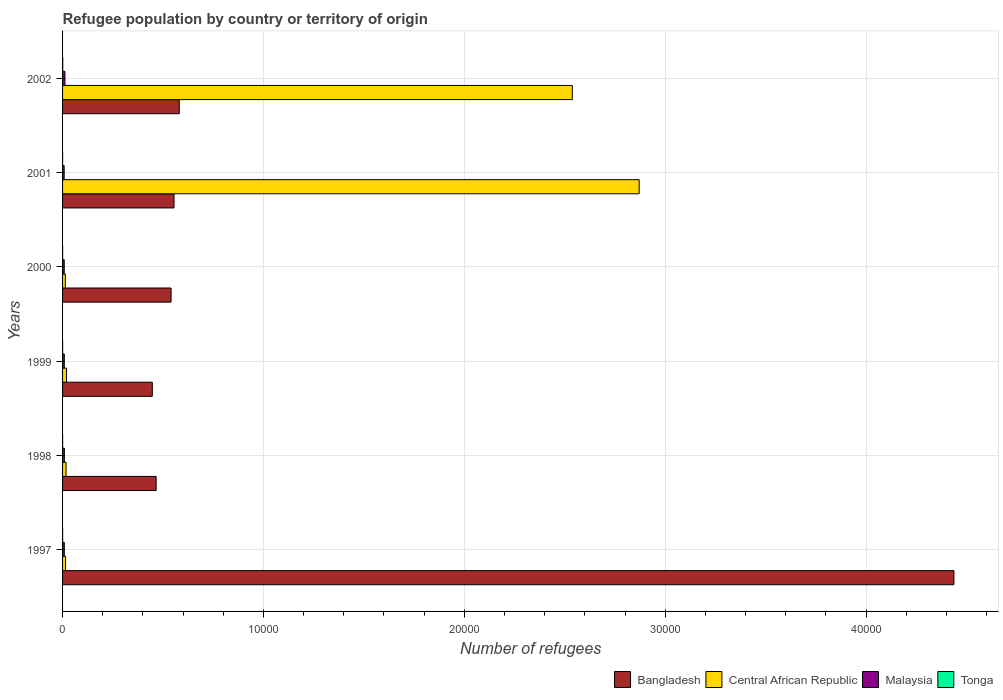How many different coloured bars are there?
Provide a succinct answer. 4. How many groups of bars are there?
Give a very brief answer. 6. Are the number of bars on each tick of the Y-axis equal?
Offer a very short reply. Yes. In how many cases, is the number of bars for a given year not equal to the number of legend labels?
Offer a terse response. 0. What is the number of refugees in Central African Republic in 2002?
Ensure brevity in your answer.  2.54e+04. Across all years, what is the maximum number of refugees in Malaysia?
Keep it short and to the point. 119. Across all years, what is the minimum number of refugees in Bangladesh?
Your answer should be compact. 4468. In which year was the number of refugees in Central African Republic maximum?
Your answer should be very brief. 2001. What is the total number of refugees in Malaysia in the graph?
Provide a succinct answer. 543. What is the difference between the number of refugees in Tonga in 1998 and the number of refugees in Malaysia in 2001?
Your response must be concise. -77. What is the average number of refugees in Bangladesh per year?
Ensure brevity in your answer.  1.17e+04. In the year 1999, what is the difference between the number of refugees in Tonga and number of refugees in Central African Republic?
Give a very brief answer. -194. What is the ratio of the number of refugees in Malaysia in 1997 to that in 1998?
Your answer should be very brief. 0.97. What is the difference between the highest and the lowest number of refugees in Tonga?
Your answer should be very brief. 7. In how many years, is the number of refugees in Central African Republic greater than the average number of refugees in Central African Republic taken over all years?
Give a very brief answer. 2. What does the 3rd bar from the top in 1998 represents?
Make the answer very short. Central African Republic. What does the 2nd bar from the bottom in 1998 represents?
Give a very brief answer. Central African Republic. Is it the case that in every year, the sum of the number of refugees in Central African Republic and number of refugees in Tonga is greater than the number of refugees in Bangladesh?
Keep it short and to the point. No. How many bars are there?
Provide a short and direct response. 24. Are all the bars in the graph horizontal?
Make the answer very short. Yes. What is the difference between two consecutive major ticks on the X-axis?
Your answer should be very brief. 10000. Are the values on the major ticks of X-axis written in scientific E-notation?
Provide a succinct answer. No. Does the graph contain any zero values?
Your answer should be compact. No. Does the graph contain grids?
Offer a very short reply. Yes. What is the title of the graph?
Keep it short and to the point. Refugee population by country or territory of origin. Does "Hong Kong" appear as one of the legend labels in the graph?
Offer a terse response. No. What is the label or title of the X-axis?
Provide a succinct answer. Number of refugees. What is the Number of refugees in Bangladesh in 1997?
Give a very brief answer. 4.44e+04. What is the Number of refugees of Central African Republic in 1997?
Your answer should be compact. 149. What is the Number of refugees in Malaysia in 1997?
Offer a terse response. 87. What is the Number of refugees in Tonga in 1997?
Give a very brief answer. 3. What is the Number of refugees of Bangladesh in 1998?
Ensure brevity in your answer.  4658. What is the Number of refugees in Central African Republic in 1998?
Offer a very short reply. 173. What is the Number of refugees of Malaysia in 1998?
Your response must be concise. 90. What is the Number of refugees of Bangladesh in 1999?
Ensure brevity in your answer.  4468. What is the Number of refugees in Central African Republic in 1999?
Ensure brevity in your answer.  196. What is the Number of refugees of Bangladesh in 2000?
Your answer should be compact. 5401. What is the Number of refugees of Central African Republic in 2000?
Provide a short and direct response. 139. What is the Number of refugees of Malaysia in 2000?
Offer a terse response. 82. What is the Number of refugees of Tonga in 2000?
Offer a terse response. 3. What is the Number of refugees in Bangladesh in 2001?
Give a very brief answer. 5548. What is the Number of refugees of Central African Republic in 2001?
Your response must be concise. 2.87e+04. What is the Number of refugees in Malaysia in 2001?
Ensure brevity in your answer.  79. What is the Number of refugees of Tonga in 2001?
Provide a succinct answer. 1. What is the Number of refugees of Bangladesh in 2002?
Make the answer very short. 5808. What is the Number of refugees of Central African Republic in 2002?
Offer a terse response. 2.54e+04. What is the Number of refugees in Malaysia in 2002?
Your answer should be compact. 119. What is the Number of refugees of Tonga in 2002?
Keep it short and to the point. 8. Across all years, what is the maximum Number of refugees of Bangladesh?
Your response must be concise. 4.44e+04. Across all years, what is the maximum Number of refugees in Central African Republic?
Provide a succinct answer. 2.87e+04. Across all years, what is the maximum Number of refugees in Malaysia?
Offer a terse response. 119. Across all years, what is the minimum Number of refugees of Bangladesh?
Give a very brief answer. 4468. Across all years, what is the minimum Number of refugees in Central African Republic?
Offer a very short reply. 139. Across all years, what is the minimum Number of refugees in Malaysia?
Provide a succinct answer. 79. What is the total Number of refugees in Bangladesh in the graph?
Give a very brief answer. 7.03e+04. What is the total Number of refugees of Central African Republic in the graph?
Your answer should be very brief. 5.47e+04. What is the total Number of refugees of Malaysia in the graph?
Give a very brief answer. 543. What is the difference between the Number of refugees in Bangladesh in 1997 and that in 1998?
Provide a succinct answer. 3.97e+04. What is the difference between the Number of refugees in Tonga in 1997 and that in 1998?
Offer a very short reply. 1. What is the difference between the Number of refugees in Bangladesh in 1997 and that in 1999?
Provide a short and direct response. 3.99e+04. What is the difference between the Number of refugees of Central African Republic in 1997 and that in 1999?
Give a very brief answer. -47. What is the difference between the Number of refugees of Malaysia in 1997 and that in 1999?
Provide a succinct answer. 1. What is the difference between the Number of refugees in Bangladesh in 1997 and that in 2000?
Your response must be concise. 3.90e+04. What is the difference between the Number of refugees of Malaysia in 1997 and that in 2000?
Give a very brief answer. 5. What is the difference between the Number of refugees in Bangladesh in 1997 and that in 2001?
Offer a very short reply. 3.88e+04. What is the difference between the Number of refugees of Central African Republic in 1997 and that in 2001?
Give a very brief answer. -2.86e+04. What is the difference between the Number of refugees in Malaysia in 1997 and that in 2001?
Offer a very short reply. 8. What is the difference between the Number of refugees in Bangladesh in 1997 and that in 2002?
Provide a succinct answer. 3.86e+04. What is the difference between the Number of refugees in Central African Republic in 1997 and that in 2002?
Give a very brief answer. -2.52e+04. What is the difference between the Number of refugees of Malaysia in 1997 and that in 2002?
Keep it short and to the point. -32. What is the difference between the Number of refugees of Bangladesh in 1998 and that in 1999?
Your answer should be compact. 190. What is the difference between the Number of refugees in Tonga in 1998 and that in 1999?
Provide a succinct answer. 0. What is the difference between the Number of refugees of Bangladesh in 1998 and that in 2000?
Offer a terse response. -743. What is the difference between the Number of refugees of Central African Republic in 1998 and that in 2000?
Keep it short and to the point. 34. What is the difference between the Number of refugees in Malaysia in 1998 and that in 2000?
Keep it short and to the point. 8. What is the difference between the Number of refugees in Tonga in 1998 and that in 2000?
Your response must be concise. -1. What is the difference between the Number of refugees of Bangladesh in 1998 and that in 2001?
Give a very brief answer. -890. What is the difference between the Number of refugees of Central African Republic in 1998 and that in 2001?
Offer a terse response. -2.85e+04. What is the difference between the Number of refugees of Malaysia in 1998 and that in 2001?
Provide a succinct answer. 11. What is the difference between the Number of refugees in Tonga in 1998 and that in 2001?
Make the answer very short. 1. What is the difference between the Number of refugees of Bangladesh in 1998 and that in 2002?
Your answer should be compact. -1150. What is the difference between the Number of refugees of Central African Republic in 1998 and that in 2002?
Ensure brevity in your answer.  -2.52e+04. What is the difference between the Number of refugees in Tonga in 1998 and that in 2002?
Offer a terse response. -6. What is the difference between the Number of refugees in Bangladesh in 1999 and that in 2000?
Offer a terse response. -933. What is the difference between the Number of refugees in Central African Republic in 1999 and that in 2000?
Give a very brief answer. 57. What is the difference between the Number of refugees in Tonga in 1999 and that in 2000?
Keep it short and to the point. -1. What is the difference between the Number of refugees of Bangladesh in 1999 and that in 2001?
Ensure brevity in your answer.  -1080. What is the difference between the Number of refugees in Central African Republic in 1999 and that in 2001?
Provide a succinct answer. -2.85e+04. What is the difference between the Number of refugees of Malaysia in 1999 and that in 2001?
Give a very brief answer. 7. What is the difference between the Number of refugees of Bangladesh in 1999 and that in 2002?
Provide a succinct answer. -1340. What is the difference between the Number of refugees in Central African Republic in 1999 and that in 2002?
Offer a terse response. -2.52e+04. What is the difference between the Number of refugees of Malaysia in 1999 and that in 2002?
Make the answer very short. -33. What is the difference between the Number of refugees in Tonga in 1999 and that in 2002?
Ensure brevity in your answer.  -6. What is the difference between the Number of refugees of Bangladesh in 2000 and that in 2001?
Provide a short and direct response. -147. What is the difference between the Number of refugees in Central African Republic in 2000 and that in 2001?
Offer a very short reply. -2.86e+04. What is the difference between the Number of refugees of Malaysia in 2000 and that in 2001?
Give a very brief answer. 3. What is the difference between the Number of refugees in Bangladesh in 2000 and that in 2002?
Your answer should be very brief. -407. What is the difference between the Number of refugees in Central African Republic in 2000 and that in 2002?
Your answer should be very brief. -2.52e+04. What is the difference between the Number of refugees in Malaysia in 2000 and that in 2002?
Ensure brevity in your answer.  -37. What is the difference between the Number of refugees of Tonga in 2000 and that in 2002?
Your answer should be very brief. -5. What is the difference between the Number of refugees in Bangladesh in 2001 and that in 2002?
Your answer should be very brief. -260. What is the difference between the Number of refugees in Central African Republic in 2001 and that in 2002?
Offer a very short reply. 3328. What is the difference between the Number of refugees of Bangladesh in 1997 and the Number of refugees of Central African Republic in 1998?
Your answer should be compact. 4.42e+04. What is the difference between the Number of refugees of Bangladesh in 1997 and the Number of refugees of Malaysia in 1998?
Ensure brevity in your answer.  4.43e+04. What is the difference between the Number of refugees in Bangladesh in 1997 and the Number of refugees in Tonga in 1998?
Give a very brief answer. 4.44e+04. What is the difference between the Number of refugees in Central African Republic in 1997 and the Number of refugees in Tonga in 1998?
Make the answer very short. 147. What is the difference between the Number of refugees in Bangladesh in 1997 and the Number of refugees in Central African Republic in 1999?
Provide a succinct answer. 4.42e+04. What is the difference between the Number of refugees of Bangladesh in 1997 and the Number of refugees of Malaysia in 1999?
Your response must be concise. 4.43e+04. What is the difference between the Number of refugees of Bangladesh in 1997 and the Number of refugees of Tonga in 1999?
Give a very brief answer. 4.44e+04. What is the difference between the Number of refugees in Central African Republic in 1997 and the Number of refugees in Tonga in 1999?
Offer a terse response. 147. What is the difference between the Number of refugees of Malaysia in 1997 and the Number of refugees of Tonga in 1999?
Your answer should be compact. 85. What is the difference between the Number of refugees of Bangladesh in 1997 and the Number of refugees of Central African Republic in 2000?
Keep it short and to the point. 4.42e+04. What is the difference between the Number of refugees in Bangladesh in 1997 and the Number of refugees in Malaysia in 2000?
Make the answer very short. 4.43e+04. What is the difference between the Number of refugees of Bangladesh in 1997 and the Number of refugees of Tonga in 2000?
Your response must be concise. 4.44e+04. What is the difference between the Number of refugees of Central African Republic in 1997 and the Number of refugees of Malaysia in 2000?
Your answer should be very brief. 67. What is the difference between the Number of refugees in Central African Republic in 1997 and the Number of refugees in Tonga in 2000?
Your answer should be compact. 146. What is the difference between the Number of refugees of Bangladesh in 1997 and the Number of refugees of Central African Republic in 2001?
Your response must be concise. 1.57e+04. What is the difference between the Number of refugees of Bangladesh in 1997 and the Number of refugees of Malaysia in 2001?
Your answer should be very brief. 4.43e+04. What is the difference between the Number of refugees in Bangladesh in 1997 and the Number of refugees in Tonga in 2001?
Offer a very short reply. 4.44e+04. What is the difference between the Number of refugees in Central African Republic in 1997 and the Number of refugees in Tonga in 2001?
Your answer should be very brief. 148. What is the difference between the Number of refugees of Bangladesh in 1997 and the Number of refugees of Central African Republic in 2002?
Your answer should be very brief. 1.90e+04. What is the difference between the Number of refugees in Bangladesh in 1997 and the Number of refugees in Malaysia in 2002?
Your answer should be very brief. 4.43e+04. What is the difference between the Number of refugees in Bangladesh in 1997 and the Number of refugees in Tonga in 2002?
Keep it short and to the point. 4.44e+04. What is the difference between the Number of refugees in Central African Republic in 1997 and the Number of refugees in Malaysia in 2002?
Provide a short and direct response. 30. What is the difference between the Number of refugees of Central African Republic in 1997 and the Number of refugees of Tonga in 2002?
Give a very brief answer. 141. What is the difference between the Number of refugees of Malaysia in 1997 and the Number of refugees of Tonga in 2002?
Offer a terse response. 79. What is the difference between the Number of refugees in Bangladesh in 1998 and the Number of refugees in Central African Republic in 1999?
Offer a very short reply. 4462. What is the difference between the Number of refugees in Bangladesh in 1998 and the Number of refugees in Malaysia in 1999?
Ensure brevity in your answer.  4572. What is the difference between the Number of refugees of Bangladesh in 1998 and the Number of refugees of Tonga in 1999?
Give a very brief answer. 4656. What is the difference between the Number of refugees of Central African Republic in 1998 and the Number of refugees of Tonga in 1999?
Your answer should be compact. 171. What is the difference between the Number of refugees in Bangladesh in 1998 and the Number of refugees in Central African Republic in 2000?
Your answer should be compact. 4519. What is the difference between the Number of refugees of Bangladesh in 1998 and the Number of refugees of Malaysia in 2000?
Give a very brief answer. 4576. What is the difference between the Number of refugees in Bangladesh in 1998 and the Number of refugees in Tonga in 2000?
Your answer should be compact. 4655. What is the difference between the Number of refugees in Central African Republic in 1998 and the Number of refugees in Malaysia in 2000?
Provide a short and direct response. 91. What is the difference between the Number of refugees in Central African Republic in 1998 and the Number of refugees in Tonga in 2000?
Your answer should be very brief. 170. What is the difference between the Number of refugees of Malaysia in 1998 and the Number of refugees of Tonga in 2000?
Your answer should be very brief. 87. What is the difference between the Number of refugees in Bangladesh in 1998 and the Number of refugees in Central African Republic in 2001?
Offer a very short reply. -2.40e+04. What is the difference between the Number of refugees in Bangladesh in 1998 and the Number of refugees in Malaysia in 2001?
Give a very brief answer. 4579. What is the difference between the Number of refugees in Bangladesh in 1998 and the Number of refugees in Tonga in 2001?
Keep it short and to the point. 4657. What is the difference between the Number of refugees of Central African Republic in 1998 and the Number of refugees of Malaysia in 2001?
Provide a short and direct response. 94. What is the difference between the Number of refugees in Central African Republic in 1998 and the Number of refugees in Tonga in 2001?
Keep it short and to the point. 172. What is the difference between the Number of refugees of Malaysia in 1998 and the Number of refugees of Tonga in 2001?
Your answer should be compact. 89. What is the difference between the Number of refugees in Bangladesh in 1998 and the Number of refugees in Central African Republic in 2002?
Offer a terse response. -2.07e+04. What is the difference between the Number of refugees of Bangladesh in 1998 and the Number of refugees of Malaysia in 2002?
Provide a short and direct response. 4539. What is the difference between the Number of refugees in Bangladesh in 1998 and the Number of refugees in Tonga in 2002?
Your answer should be very brief. 4650. What is the difference between the Number of refugees of Central African Republic in 1998 and the Number of refugees of Malaysia in 2002?
Make the answer very short. 54. What is the difference between the Number of refugees of Central African Republic in 1998 and the Number of refugees of Tonga in 2002?
Provide a short and direct response. 165. What is the difference between the Number of refugees in Malaysia in 1998 and the Number of refugees in Tonga in 2002?
Your response must be concise. 82. What is the difference between the Number of refugees of Bangladesh in 1999 and the Number of refugees of Central African Republic in 2000?
Provide a succinct answer. 4329. What is the difference between the Number of refugees in Bangladesh in 1999 and the Number of refugees in Malaysia in 2000?
Your answer should be compact. 4386. What is the difference between the Number of refugees of Bangladesh in 1999 and the Number of refugees of Tonga in 2000?
Give a very brief answer. 4465. What is the difference between the Number of refugees in Central African Republic in 1999 and the Number of refugees in Malaysia in 2000?
Give a very brief answer. 114. What is the difference between the Number of refugees in Central African Republic in 1999 and the Number of refugees in Tonga in 2000?
Provide a succinct answer. 193. What is the difference between the Number of refugees in Malaysia in 1999 and the Number of refugees in Tonga in 2000?
Offer a very short reply. 83. What is the difference between the Number of refugees of Bangladesh in 1999 and the Number of refugees of Central African Republic in 2001?
Ensure brevity in your answer.  -2.42e+04. What is the difference between the Number of refugees in Bangladesh in 1999 and the Number of refugees in Malaysia in 2001?
Make the answer very short. 4389. What is the difference between the Number of refugees of Bangladesh in 1999 and the Number of refugees of Tonga in 2001?
Offer a terse response. 4467. What is the difference between the Number of refugees of Central African Republic in 1999 and the Number of refugees of Malaysia in 2001?
Give a very brief answer. 117. What is the difference between the Number of refugees in Central African Republic in 1999 and the Number of refugees in Tonga in 2001?
Give a very brief answer. 195. What is the difference between the Number of refugees in Bangladesh in 1999 and the Number of refugees in Central African Republic in 2002?
Your answer should be very brief. -2.09e+04. What is the difference between the Number of refugees of Bangladesh in 1999 and the Number of refugees of Malaysia in 2002?
Ensure brevity in your answer.  4349. What is the difference between the Number of refugees in Bangladesh in 1999 and the Number of refugees in Tonga in 2002?
Your response must be concise. 4460. What is the difference between the Number of refugees of Central African Republic in 1999 and the Number of refugees of Tonga in 2002?
Keep it short and to the point. 188. What is the difference between the Number of refugees in Malaysia in 1999 and the Number of refugees in Tonga in 2002?
Offer a terse response. 78. What is the difference between the Number of refugees in Bangladesh in 2000 and the Number of refugees in Central African Republic in 2001?
Provide a short and direct response. -2.33e+04. What is the difference between the Number of refugees in Bangladesh in 2000 and the Number of refugees in Malaysia in 2001?
Provide a succinct answer. 5322. What is the difference between the Number of refugees in Bangladesh in 2000 and the Number of refugees in Tonga in 2001?
Ensure brevity in your answer.  5400. What is the difference between the Number of refugees of Central African Republic in 2000 and the Number of refugees of Tonga in 2001?
Give a very brief answer. 138. What is the difference between the Number of refugees of Malaysia in 2000 and the Number of refugees of Tonga in 2001?
Offer a very short reply. 81. What is the difference between the Number of refugees of Bangladesh in 2000 and the Number of refugees of Central African Republic in 2002?
Keep it short and to the point. -2.00e+04. What is the difference between the Number of refugees of Bangladesh in 2000 and the Number of refugees of Malaysia in 2002?
Offer a very short reply. 5282. What is the difference between the Number of refugees in Bangladesh in 2000 and the Number of refugees in Tonga in 2002?
Your answer should be compact. 5393. What is the difference between the Number of refugees in Central African Republic in 2000 and the Number of refugees in Malaysia in 2002?
Offer a terse response. 20. What is the difference between the Number of refugees in Central African Republic in 2000 and the Number of refugees in Tonga in 2002?
Offer a very short reply. 131. What is the difference between the Number of refugees in Malaysia in 2000 and the Number of refugees in Tonga in 2002?
Your answer should be compact. 74. What is the difference between the Number of refugees in Bangladesh in 2001 and the Number of refugees in Central African Republic in 2002?
Provide a succinct answer. -1.98e+04. What is the difference between the Number of refugees in Bangladesh in 2001 and the Number of refugees in Malaysia in 2002?
Your response must be concise. 5429. What is the difference between the Number of refugees in Bangladesh in 2001 and the Number of refugees in Tonga in 2002?
Your answer should be very brief. 5540. What is the difference between the Number of refugees of Central African Republic in 2001 and the Number of refugees of Malaysia in 2002?
Provide a short and direct response. 2.86e+04. What is the difference between the Number of refugees in Central African Republic in 2001 and the Number of refugees in Tonga in 2002?
Offer a terse response. 2.87e+04. What is the average Number of refugees in Bangladesh per year?
Provide a succinct answer. 1.17e+04. What is the average Number of refugees in Central African Republic per year?
Offer a terse response. 9122.83. What is the average Number of refugees in Malaysia per year?
Your answer should be very brief. 90.5. What is the average Number of refugees in Tonga per year?
Make the answer very short. 3.17. In the year 1997, what is the difference between the Number of refugees of Bangladesh and Number of refugees of Central African Republic?
Offer a terse response. 4.42e+04. In the year 1997, what is the difference between the Number of refugees in Bangladesh and Number of refugees in Malaysia?
Offer a very short reply. 4.43e+04. In the year 1997, what is the difference between the Number of refugees in Bangladesh and Number of refugees in Tonga?
Your answer should be compact. 4.44e+04. In the year 1997, what is the difference between the Number of refugees in Central African Republic and Number of refugees in Malaysia?
Your response must be concise. 62. In the year 1997, what is the difference between the Number of refugees of Central African Republic and Number of refugees of Tonga?
Your response must be concise. 146. In the year 1998, what is the difference between the Number of refugees in Bangladesh and Number of refugees in Central African Republic?
Your answer should be very brief. 4485. In the year 1998, what is the difference between the Number of refugees in Bangladesh and Number of refugees in Malaysia?
Offer a very short reply. 4568. In the year 1998, what is the difference between the Number of refugees in Bangladesh and Number of refugees in Tonga?
Give a very brief answer. 4656. In the year 1998, what is the difference between the Number of refugees of Central African Republic and Number of refugees of Malaysia?
Offer a very short reply. 83. In the year 1998, what is the difference between the Number of refugees in Central African Republic and Number of refugees in Tonga?
Give a very brief answer. 171. In the year 1998, what is the difference between the Number of refugees in Malaysia and Number of refugees in Tonga?
Offer a very short reply. 88. In the year 1999, what is the difference between the Number of refugees of Bangladesh and Number of refugees of Central African Republic?
Offer a very short reply. 4272. In the year 1999, what is the difference between the Number of refugees in Bangladesh and Number of refugees in Malaysia?
Your answer should be very brief. 4382. In the year 1999, what is the difference between the Number of refugees in Bangladesh and Number of refugees in Tonga?
Offer a terse response. 4466. In the year 1999, what is the difference between the Number of refugees in Central African Republic and Number of refugees in Malaysia?
Your answer should be compact. 110. In the year 1999, what is the difference between the Number of refugees in Central African Republic and Number of refugees in Tonga?
Keep it short and to the point. 194. In the year 2000, what is the difference between the Number of refugees in Bangladesh and Number of refugees in Central African Republic?
Make the answer very short. 5262. In the year 2000, what is the difference between the Number of refugees of Bangladesh and Number of refugees of Malaysia?
Make the answer very short. 5319. In the year 2000, what is the difference between the Number of refugees in Bangladesh and Number of refugees in Tonga?
Your answer should be very brief. 5398. In the year 2000, what is the difference between the Number of refugees in Central African Republic and Number of refugees in Tonga?
Your answer should be very brief. 136. In the year 2000, what is the difference between the Number of refugees of Malaysia and Number of refugees of Tonga?
Your response must be concise. 79. In the year 2001, what is the difference between the Number of refugees of Bangladesh and Number of refugees of Central African Republic?
Offer a terse response. -2.32e+04. In the year 2001, what is the difference between the Number of refugees in Bangladesh and Number of refugees in Malaysia?
Your response must be concise. 5469. In the year 2001, what is the difference between the Number of refugees in Bangladesh and Number of refugees in Tonga?
Your answer should be very brief. 5547. In the year 2001, what is the difference between the Number of refugees of Central African Republic and Number of refugees of Malaysia?
Your response must be concise. 2.86e+04. In the year 2001, what is the difference between the Number of refugees in Central African Republic and Number of refugees in Tonga?
Ensure brevity in your answer.  2.87e+04. In the year 2001, what is the difference between the Number of refugees in Malaysia and Number of refugees in Tonga?
Offer a very short reply. 78. In the year 2002, what is the difference between the Number of refugees in Bangladesh and Number of refugees in Central African Republic?
Offer a very short reply. -1.96e+04. In the year 2002, what is the difference between the Number of refugees of Bangladesh and Number of refugees of Malaysia?
Make the answer very short. 5689. In the year 2002, what is the difference between the Number of refugees of Bangladesh and Number of refugees of Tonga?
Give a very brief answer. 5800. In the year 2002, what is the difference between the Number of refugees in Central African Republic and Number of refugees in Malaysia?
Ensure brevity in your answer.  2.53e+04. In the year 2002, what is the difference between the Number of refugees of Central African Republic and Number of refugees of Tonga?
Offer a terse response. 2.54e+04. In the year 2002, what is the difference between the Number of refugees of Malaysia and Number of refugees of Tonga?
Your answer should be compact. 111. What is the ratio of the Number of refugees of Bangladesh in 1997 to that in 1998?
Your answer should be very brief. 9.53. What is the ratio of the Number of refugees in Central African Republic in 1997 to that in 1998?
Make the answer very short. 0.86. What is the ratio of the Number of refugees in Malaysia in 1997 to that in 1998?
Ensure brevity in your answer.  0.97. What is the ratio of the Number of refugees of Tonga in 1997 to that in 1998?
Offer a very short reply. 1.5. What is the ratio of the Number of refugees of Bangladesh in 1997 to that in 1999?
Provide a succinct answer. 9.93. What is the ratio of the Number of refugees of Central African Republic in 1997 to that in 1999?
Your response must be concise. 0.76. What is the ratio of the Number of refugees of Malaysia in 1997 to that in 1999?
Your answer should be very brief. 1.01. What is the ratio of the Number of refugees in Bangladesh in 1997 to that in 2000?
Offer a terse response. 8.22. What is the ratio of the Number of refugees in Central African Republic in 1997 to that in 2000?
Make the answer very short. 1.07. What is the ratio of the Number of refugees in Malaysia in 1997 to that in 2000?
Your answer should be very brief. 1.06. What is the ratio of the Number of refugees of Tonga in 1997 to that in 2000?
Offer a terse response. 1. What is the ratio of the Number of refugees in Bangladesh in 1997 to that in 2001?
Your answer should be very brief. 8. What is the ratio of the Number of refugees in Central African Republic in 1997 to that in 2001?
Your response must be concise. 0.01. What is the ratio of the Number of refugees of Malaysia in 1997 to that in 2001?
Your response must be concise. 1.1. What is the ratio of the Number of refugees in Bangladesh in 1997 to that in 2002?
Your response must be concise. 7.64. What is the ratio of the Number of refugees of Central African Republic in 1997 to that in 2002?
Keep it short and to the point. 0.01. What is the ratio of the Number of refugees of Malaysia in 1997 to that in 2002?
Provide a succinct answer. 0.73. What is the ratio of the Number of refugees of Bangladesh in 1998 to that in 1999?
Your answer should be compact. 1.04. What is the ratio of the Number of refugees of Central African Republic in 1998 to that in 1999?
Offer a terse response. 0.88. What is the ratio of the Number of refugees in Malaysia in 1998 to that in 1999?
Keep it short and to the point. 1.05. What is the ratio of the Number of refugees in Bangladesh in 1998 to that in 2000?
Your answer should be very brief. 0.86. What is the ratio of the Number of refugees in Central African Republic in 1998 to that in 2000?
Your answer should be very brief. 1.24. What is the ratio of the Number of refugees of Malaysia in 1998 to that in 2000?
Give a very brief answer. 1.1. What is the ratio of the Number of refugees of Bangladesh in 1998 to that in 2001?
Keep it short and to the point. 0.84. What is the ratio of the Number of refugees in Central African Republic in 1998 to that in 2001?
Your response must be concise. 0.01. What is the ratio of the Number of refugees of Malaysia in 1998 to that in 2001?
Your answer should be very brief. 1.14. What is the ratio of the Number of refugees of Bangladesh in 1998 to that in 2002?
Give a very brief answer. 0.8. What is the ratio of the Number of refugees in Central African Republic in 1998 to that in 2002?
Provide a succinct answer. 0.01. What is the ratio of the Number of refugees in Malaysia in 1998 to that in 2002?
Keep it short and to the point. 0.76. What is the ratio of the Number of refugees of Bangladesh in 1999 to that in 2000?
Your answer should be compact. 0.83. What is the ratio of the Number of refugees in Central African Republic in 1999 to that in 2000?
Keep it short and to the point. 1.41. What is the ratio of the Number of refugees of Malaysia in 1999 to that in 2000?
Make the answer very short. 1.05. What is the ratio of the Number of refugees in Tonga in 1999 to that in 2000?
Provide a succinct answer. 0.67. What is the ratio of the Number of refugees in Bangladesh in 1999 to that in 2001?
Offer a terse response. 0.81. What is the ratio of the Number of refugees in Central African Republic in 1999 to that in 2001?
Provide a succinct answer. 0.01. What is the ratio of the Number of refugees of Malaysia in 1999 to that in 2001?
Your response must be concise. 1.09. What is the ratio of the Number of refugees of Tonga in 1999 to that in 2001?
Offer a very short reply. 2. What is the ratio of the Number of refugees in Bangladesh in 1999 to that in 2002?
Ensure brevity in your answer.  0.77. What is the ratio of the Number of refugees of Central African Republic in 1999 to that in 2002?
Your answer should be very brief. 0.01. What is the ratio of the Number of refugees in Malaysia in 1999 to that in 2002?
Your answer should be very brief. 0.72. What is the ratio of the Number of refugees of Tonga in 1999 to that in 2002?
Give a very brief answer. 0.25. What is the ratio of the Number of refugees of Bangladesh in 2000 to that in 2001?
Your answer should be very brief. 0.97. What is the ratio of the Number of refugees in Central African Republic in 2000 to that in 2001?
Provide a short and direct response. 0. What is the ratio of the Number of refugees in Malaysia in 2000 to that in 2001?
Offer a terse response. 1.04. What is the ratio of the Number of refugees in Bangladesh in 2000 to that in 2002?
Offer a terse response. 0.93. What is the ratio of the Number of refugees in Central African Republic in 2000 to that in 2002?
Provide a succinct answer. 0.01. What is the ratio of the Number of refugees in Malaysia in 2000 to that in 2002?
Make the answer very short. 0.69. What is the ratio of the Number of refugees of Tonga in 2000 to that in 2002?
Provide a succinct answer. 0.38. What is the ratio of the Number of refugees in Bangladesh in 2001 to that in 2002?
Offer a terse response. 0.96. What is the ratio of the Number of refugees of Central African Republic in 2001 to that in 2002?
Ensure brevity in your answer.  1.13. What is the ratio of the Number of refugees in Malaysia in 2001 to that in 2002?
Provide a succinct answer. 0.66. What is the difference between the highest and the second highest Number of refugees of Bangladesh?
Your response must be concise. 3.86e+04. What is the difference between the highest and the second highest Number of refugees of Central African Republic?
Offer a very short reply. 3328. What is the difference between the highest and the second highest Number of refugees of Malaysia?
Keep it short and to the point. 29. What is the difference between the highest and the second highest Number of refugees of Tonga?
Your answer should be compact. 5. What is the difference between the highest and the lowest Number of refugees of Bangladesh?
Offer a very short reply. 3.99e+04. What is the difference between the highest and the lowest Number of refugees in Central African Republic?
Your answer should be very brief. 2.86e+04. What is the difference between the highest and the lowest Number of refugees of Malaysia?
Offer a terse response. 40. What is the difference between the highest and the lowest Number of refugees of Tonga?
Provide a short and direct response. 7. 